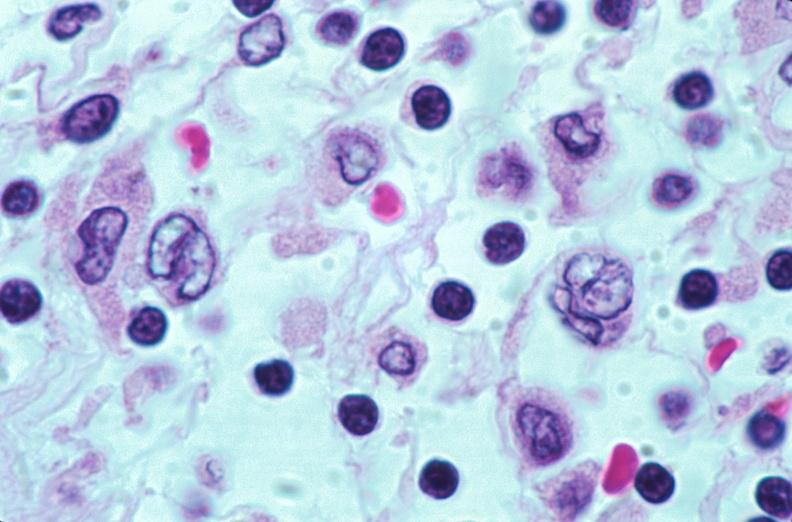does side show lymph nodes, nodular sclerosing hodgkins disease?
Answer the question using a single word or phrase. No 